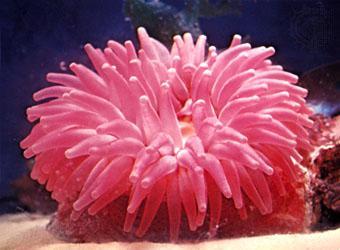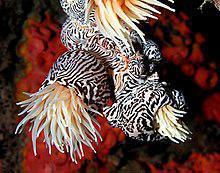The first image is the image on the left, the second image is the image on the right. Considering the images on both sides, is "A sea anemone is a solid color pink and there are no fish swimming around it." valid? Answer yes or no. Yes. 